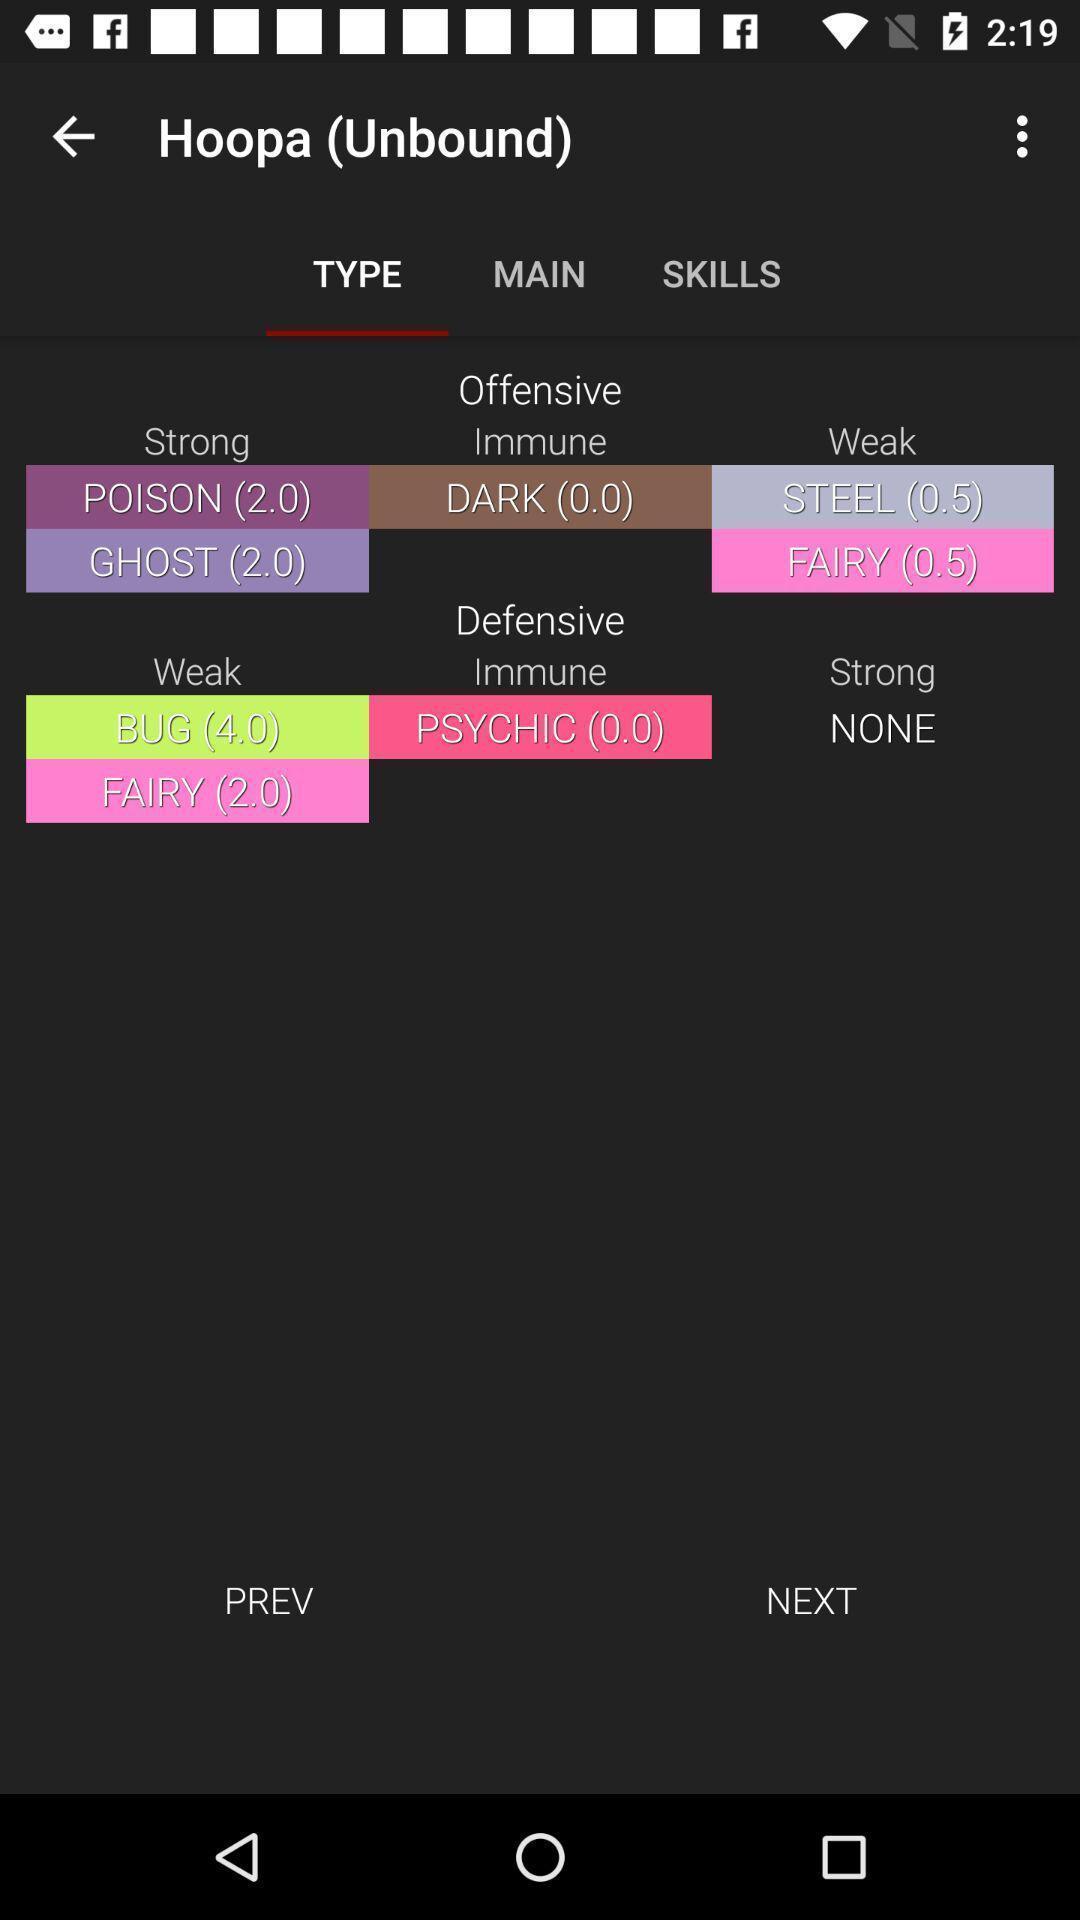Give me a summary of this screen capture. Page displaying with list of different types with few options. 